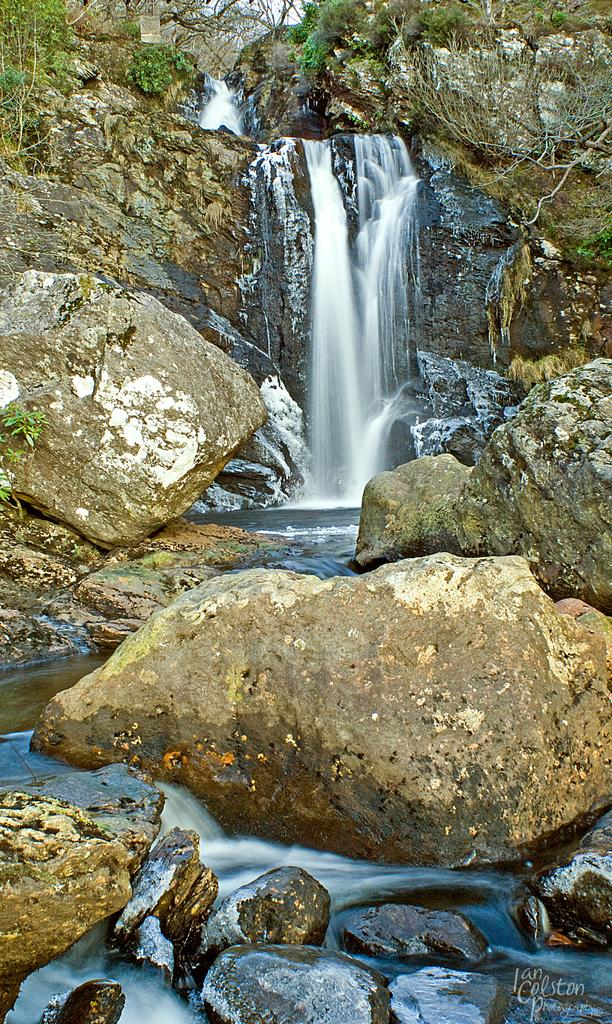What natural feature is the main subject of the image? There is a waterfall in the image. Is there any text or marking on the image? Yes, there is a watermark in the bottom right corner of the image. What type of terrain is visible in the image? Stones are visible in the image. What type of vegetation is present in the image? There is grass in the top left corner of the image. How many pizzas are being served at the waterfall in the image? There are no pizzas present in the image; it features a waterfall and its surrounding environment. What type of sweater is the waterfall wearing in the image? The waterfall is a natural feature and does not wear clothing, including sweaters. 